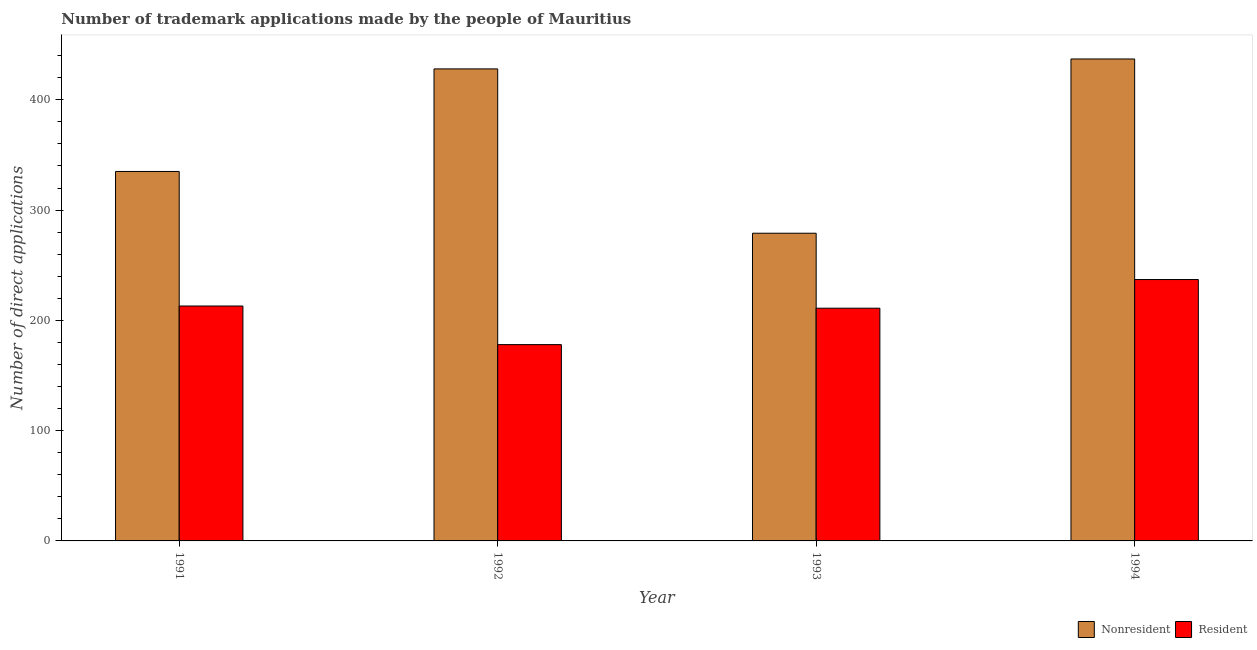How many different coloured bars are there?
Your response must be concise. 2. Are the number of bars per tick equal to the number of legend labels?
Your answer should be compact. Yes. How many bars are there on the 2nd tick from the left?
Provide a short and direct response. 2. What is the number of trademark applications made by non residents in 1994?
Ensure brevity in your answer.  437. Across all years, what is the maximum number of trademark applications made by residents?
Offer a terse response. 237. Across all years, what is the minimum number of trademark applications made by residents?
Provide a succinct answer. 178. What is the total number of trademark applications made by residents in the graph?
Offer a very short reply. 839. What is the difference between the number of trademark applications made by non residents in 1992 and that in 1994?
Make the answer very short. -9. What is the difference between the number of trademark applications made by non residents in 1991 and the number of trademark applications made by residents in 1993?
Provide a succinct answer. 56. What is the average number of trademark applications made by non residents per year?
Keep it short and to the point. 369.75. In how many years, is the number of trademark applications made by non residents greater than 120?
Your answer should be compact. 4. What is the ratio of the number of trademark applications made by non residents in 1992 to that in 1993?
Keep it short and to the point. 1.53. Is the difference between the number of trademark applications made by residents in 1992 and 1993 greater than the difference between the number of trademark applications made by non residents in 1992 and 1993?
Make the answer very short. No. What is the difference between the highest and the second highest number of trademark applications made by non residents?
Your answer should be very brief. 9. What is the difference between the highest and the lowest number of trademark applications made by residents?
Ensure brevity in your answer.  59. In how many years, is the number of trademark applications made by non residents greater than the average number of trademark applications made by non residents taken over all years?
Give a very brief answer. 2. What does the 1st bar from the left in 1994 represents?
Give a very brief answer. Nonresident. What does the 1st bar from the right in 1994 represents?
Provide a short and direct response. Resident. How many years are there in the graph?
Offer a very short reply. 4. Are the values on the major ticks of Y-axis written in scientific E-notation?
Your response must be concise. No. Does the graph contain any zero values?
Make the answer very short. No. Does the graph contain grids?
Offer a very short reply. No. Where does the legend appear in the graph?
Offer a terse response. Bottom right. How many legend labels are there?
Offer a very short reply. 2. How are the legend labels stacked?
Give a very brief answer. Horizontal. What is the title of the graph?
Your answer should be very brief. Number of trademark applications made by the people of Mauritius. What is the label or title of the Y-axis?
Make the answer very short. Number of direct applications. What is the Number of direct applications of Nonresident in 1991?
Your response must be concise. 335. What is the Number of direct applications of Resident in 1991?
Provide a short and direct response. 213. What is the Number of direct applications in Nonresident in 1992?
Offer a terse response. 428. What is the Number of direct applications of Resident in 1992?
Offer a terse response. 178. What is the Number of direct applications in Nonresident in 1993?
Your answer should be compact. 279. What is the Number of direct applications in Resident in 1993?
Your answer should be very brief. 211. What is the Number of direct applications in Nonresident in 1994?
Provide a succinct answer. 437. What is the Number of direct applications of Resident in 1994?
Give a very brief answer. 237. Across all years, what is the maximum Number of direct applications in Nonresident?
Your answer should be compact. 437. Across all years, what is the maximum Number of direct applications in Resident?
Your answer should be very brief. 237. Across all years, what is the minimum Number of direct applications of Nonresident?
Your answer should be very brief. 279. Across all years, what is the minimum Number of direct applications in Resident?
Make the answer very short. 178. What is the total Number of direct applications of Nonresident in the graph?
Provide a succinct answer. 1479. What is the total Number of direct applications in Resident in the graph?
Offer a very short reply. 839. What is the difference between the Number of direct applications in Nonresident in 1991 and that in 1992?
Provide a short and direct response. -93. What is the difference between the Number of direct applications of Resident in 1991 and that in 1992?
Ensure brevity in your answer.  35. What is the difference between the Number of direct applications of Nonresident in 1991 and that in 1993?
Your answer should be compact. 56. What is the difference between the Number of direct applications of Nonresident in 1991 and that in 1994?
Provide a short and direct response. -102. What is the difference between the Number of direct applications of Nonresident in 1992 and that in 1993?
Offer a very short reply. 149. What is the difference between the Number of direct applications in Resident in 1992 and that in 1993?
Offer a very short reply. -33. What is the difference between the Number of direct applications of Resident in 1992 and that in 1994?
Keep it short and to the point. -59. What is the difference between the Number of direct applications in Nonresident in 1993 and that in 1994?
Make the answer very short. -158. What is the difference between the Number of direct applications in Nonresident in 1991 and the Number of direct applications in Resident in 1992?
Keep it short and to the point. 157. What is the difference between the Number of direct applications of Nonresident in 1991 and the Number of direct applications of Resident in 1993?
Give a very brief answer. 124. What is the difference between the Number of direct applications in Nonresident in 1991 and the Number of direct applications in Resident in 1994?
Provide a short and direct response. 98. What is the difference between the Number of direct applications in Nonresident in 1992 and the Number of direct applications in Resident in 1993?
Provide a succinct answer. 217. What is the difference between the Number of direct applications of Nonresident in 1992 and the Number of direct applications of Resident in 1994?
Offer a very short reply. 191. What is the difference between the Number of direct applications of Nonresident in 1993 and the Number of direct applications of Resident in 1994?
Your answer should be compact. 42. What is the average Number of direct applications in Nonresident per year?
Your response must be concise. 369.75. What is the average Number of direct applications in Resident per year?
Keep it short and to the point. 209.75. In the year 1991, what is the difference between the Number of direct applications in Nonresident and Number of direct applications in Resident?
Your answer should be compact. 122. In the year 1992, what is the difference between the Number of direct applications of Nonresident and Number of direct applications of Resident?
Provide a short and direct response. 250. In the year 1993, what is the difference between the Number of direct applications of Nonresident and Number of direct applications of Resident?
Your answer should be very brief. 68. What is the ratio of the Number of direct applications of Nonresident in 1991 to that in 1992?
Offer a terse response. 0.78. What is the ratio of the Number of direct applications of Resident in 1991 to that in 1992?
Your answer should be compact. 1.2. What is the ratio of the Number of direct applications in Nonresident in 1991 to that in 1993?
Your answer should be compact. 1.2. What is the ratio of the Number of direct applications in Resident in 1991 to that in 1993?
Provide a succinct answer. 1.01. What is the ratio of the Number of direct applications in Nonresident in 1991 to that in 1994?
Your answer should be very brief. 0.77. What is the ratio of the Number of direct applications in Resident in 1991 to that in 1994?
Ensure brevity in your answer.  0.9. What is the ratio of the Number of direct applications of Nonresident in 1992 to that in 1993?
Ensure brevity in your answer.  1.53. What is the ratio of the Number of direct applications in Resident in 1992 to that in 1993?
Offer a very short reply. 0.84. What is the ratio of the Number of direct applications in Nonresident in 1992 to that in 1994?
Your answer should be very brief. 0.98. What is the ratio of the Number of direct applications in Resident in 1992 to that in 1994?
Make the answer very short. 0.75. What is the ratio of the Number of direct applications of Nonresident in 1993 to that in 1994?
Your response must be concise. 0.64. What is the ratio of the Number of direct applications of Resident in 1993 to that in 1994?
Make the answer very short. 0.89. What is the difference between the highest and the lowest Number of direct applications of Nonresident?
Offer a terse response. 158. 